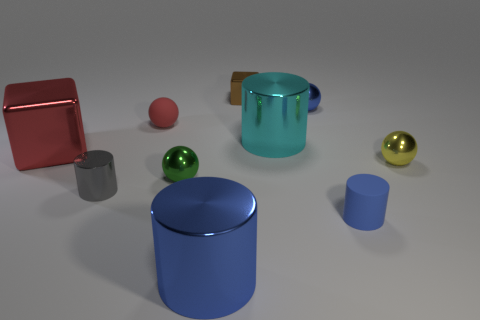Subtract all small shiny cylinders. How many cylinders are left? 3 Subtract 2 blocks. How many blocks are left? 0 Subtract all gray spheres. Subtract all blue blocks. How many spheres are left? 4 Subtract all cyan cylinders. How many red blocks are left? 1 Subtract all large purple shiny spheres. Subtract all yellow metal things. How many objects are left? 9 Add 5 red matte objects. How many red matte objects are left? 6 Add 9 tiny gray metal things. How many tiny gray metal things exist? 10 Subtract all blue cylinders. How many cylinders are left? 2 Subtract 1 cyan cylinders. How many objects are left? 9 Subtract all cubes. How many objects are left? 8 